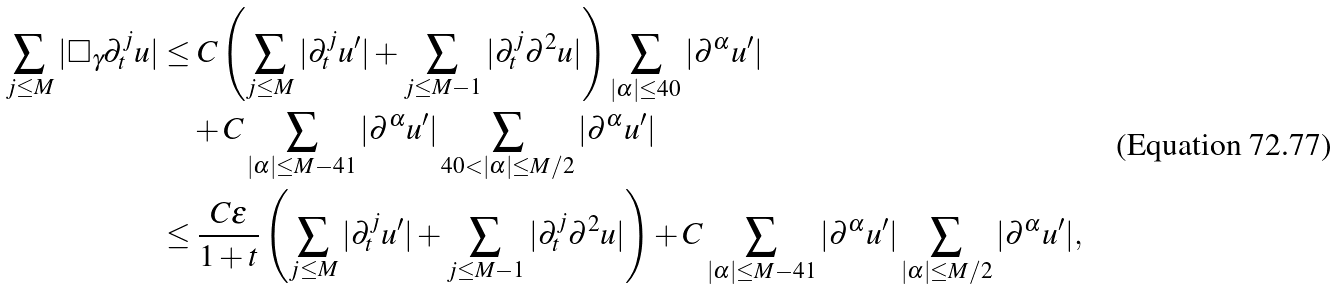<formula> <loc_0><loc_0><loc_500><loc_500>\sum _ { j \leq M } | \square _ { \gamma } \partial ^ { j } _ { t } u | & \leq C \left ( \sum _ { j \leq M } | \partial ^ { j } _ { t } u ^ { \prime } | + \sum _ { j \leq M - 1 } | \partial ^ { j } _ { t } \partial ^ { 2 } u | \right ) \sum _ { | \alpha | \leq 4 0 } | \partial ^ { \alpha } u ^ { \prime } | \\ & \quad + C \sum _ { | \alpha | \leq M - 4 1 } | \partial ^ { \alpha } u ^ { \prime } | \sum _ { 4 0 < | \alpha | \leq M / 2 } | \partial ^ { \alpha } u ^ { \prime } | \\ & \leq \frac { C \varepsilon } { 1 + t } \left ( \sum _ { j \leq M } | \partial ^ { j } _ { t } u ^ { \prime } | + \sum _ { j \leq M - 1 } | \partial ^ { j } _ { t } \partial ^ { 2 } u | \right ) + C \sum _ { | \alpha | \leq M - 4 1 } | \partial ^ { \alpha } u ^ { \prime } | \sum _ { | \alpha | \leq M / 2 } | \partial ^ { \alpha } u ^ { \prime } | ,</formula> 